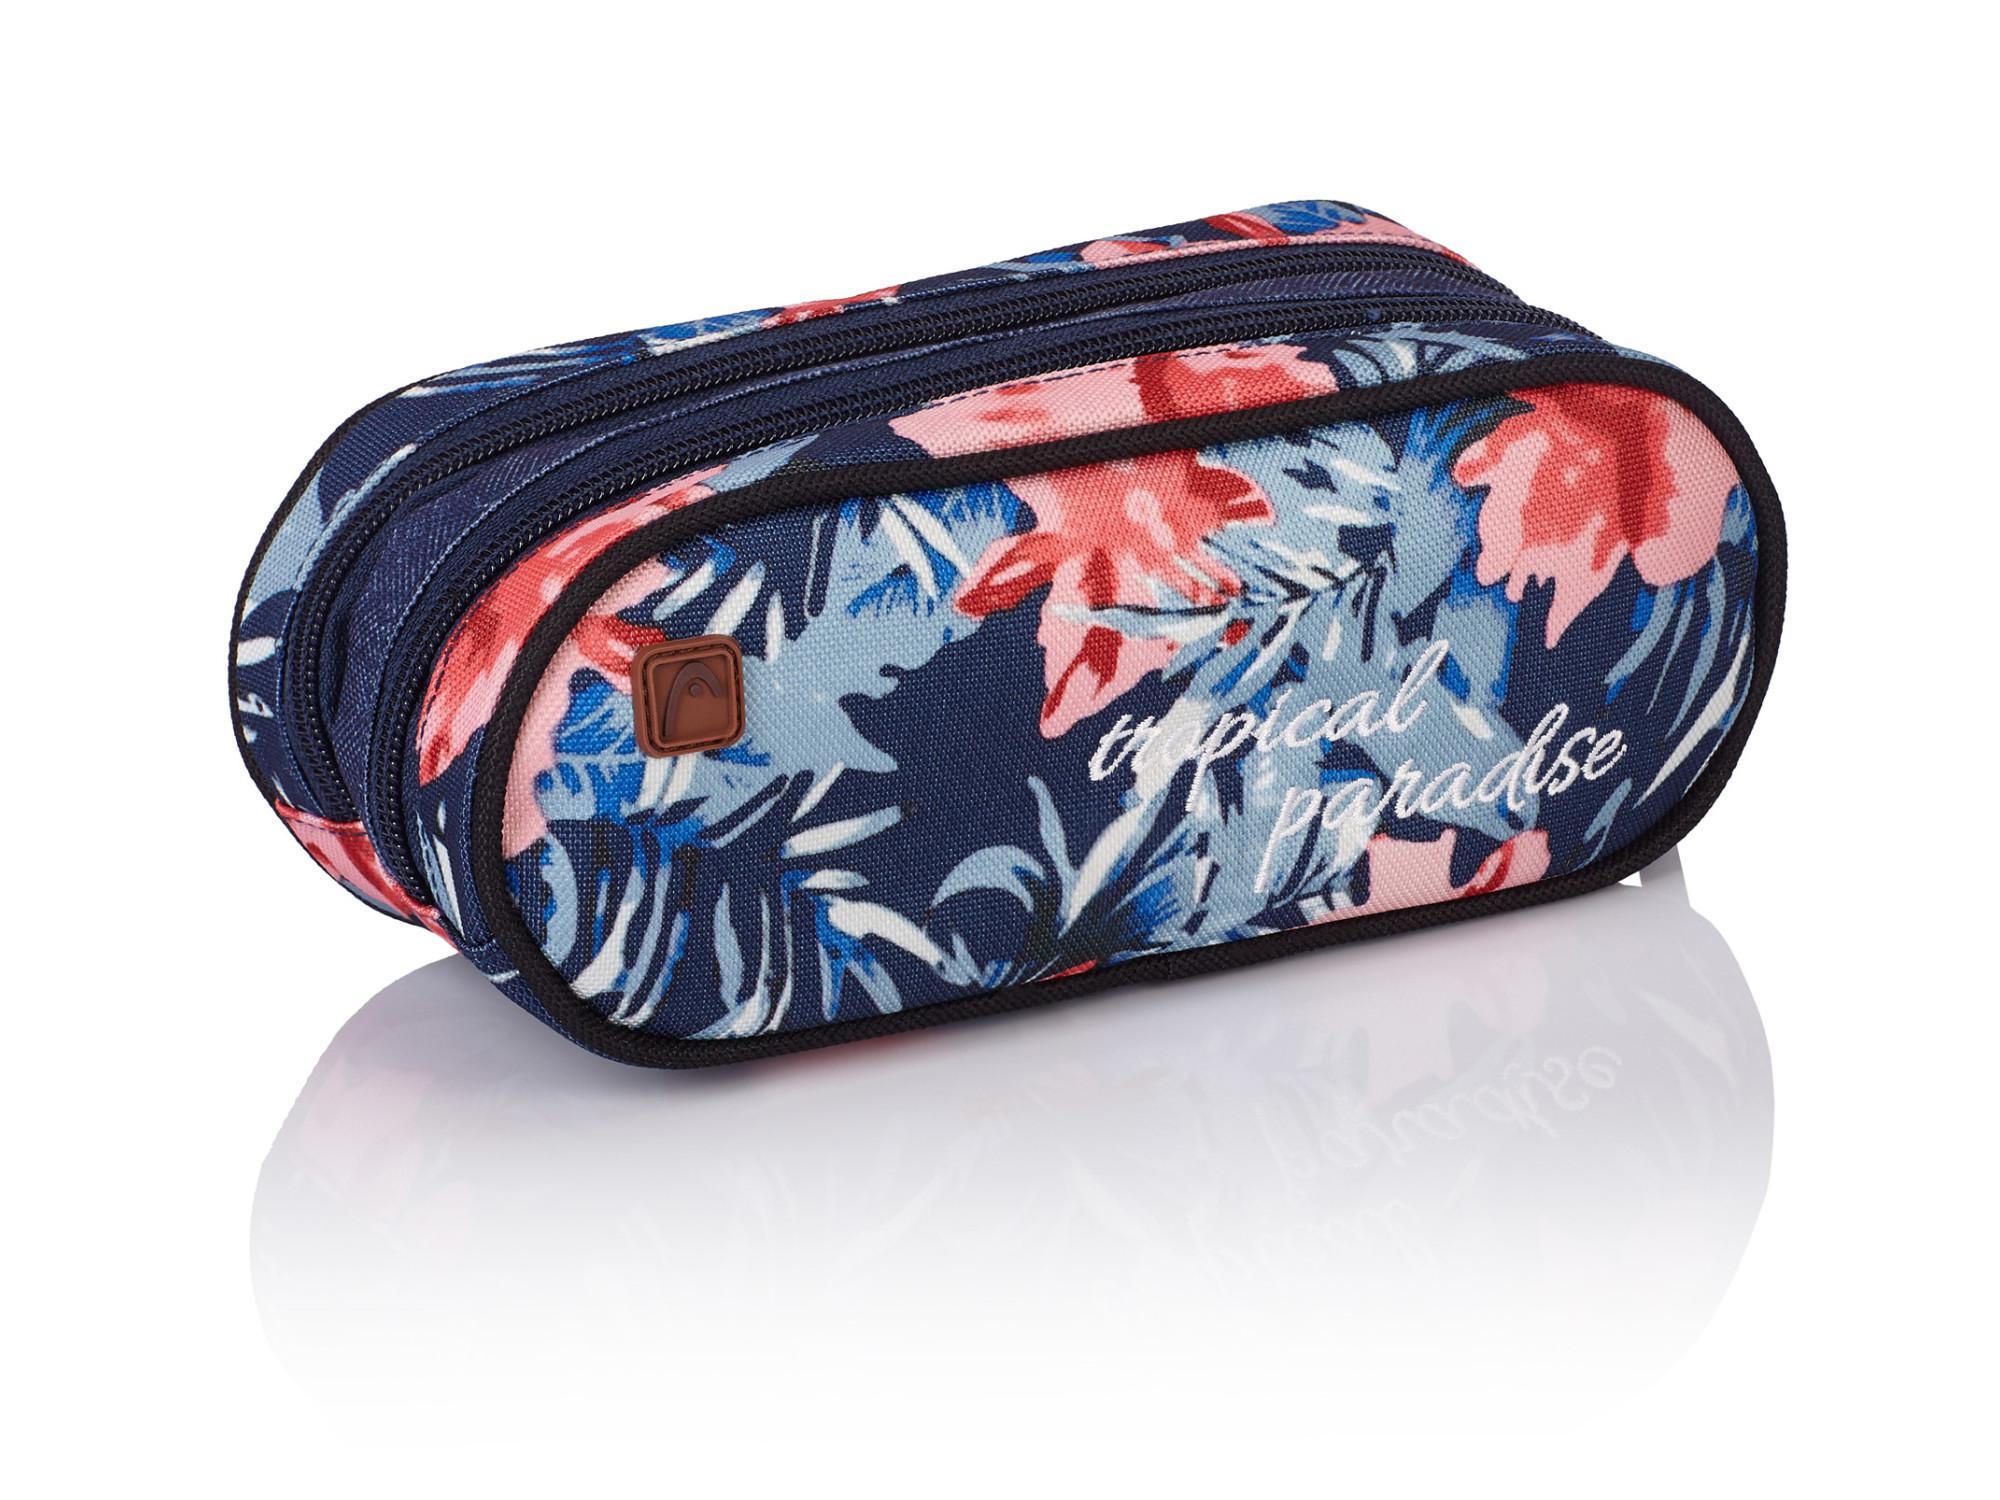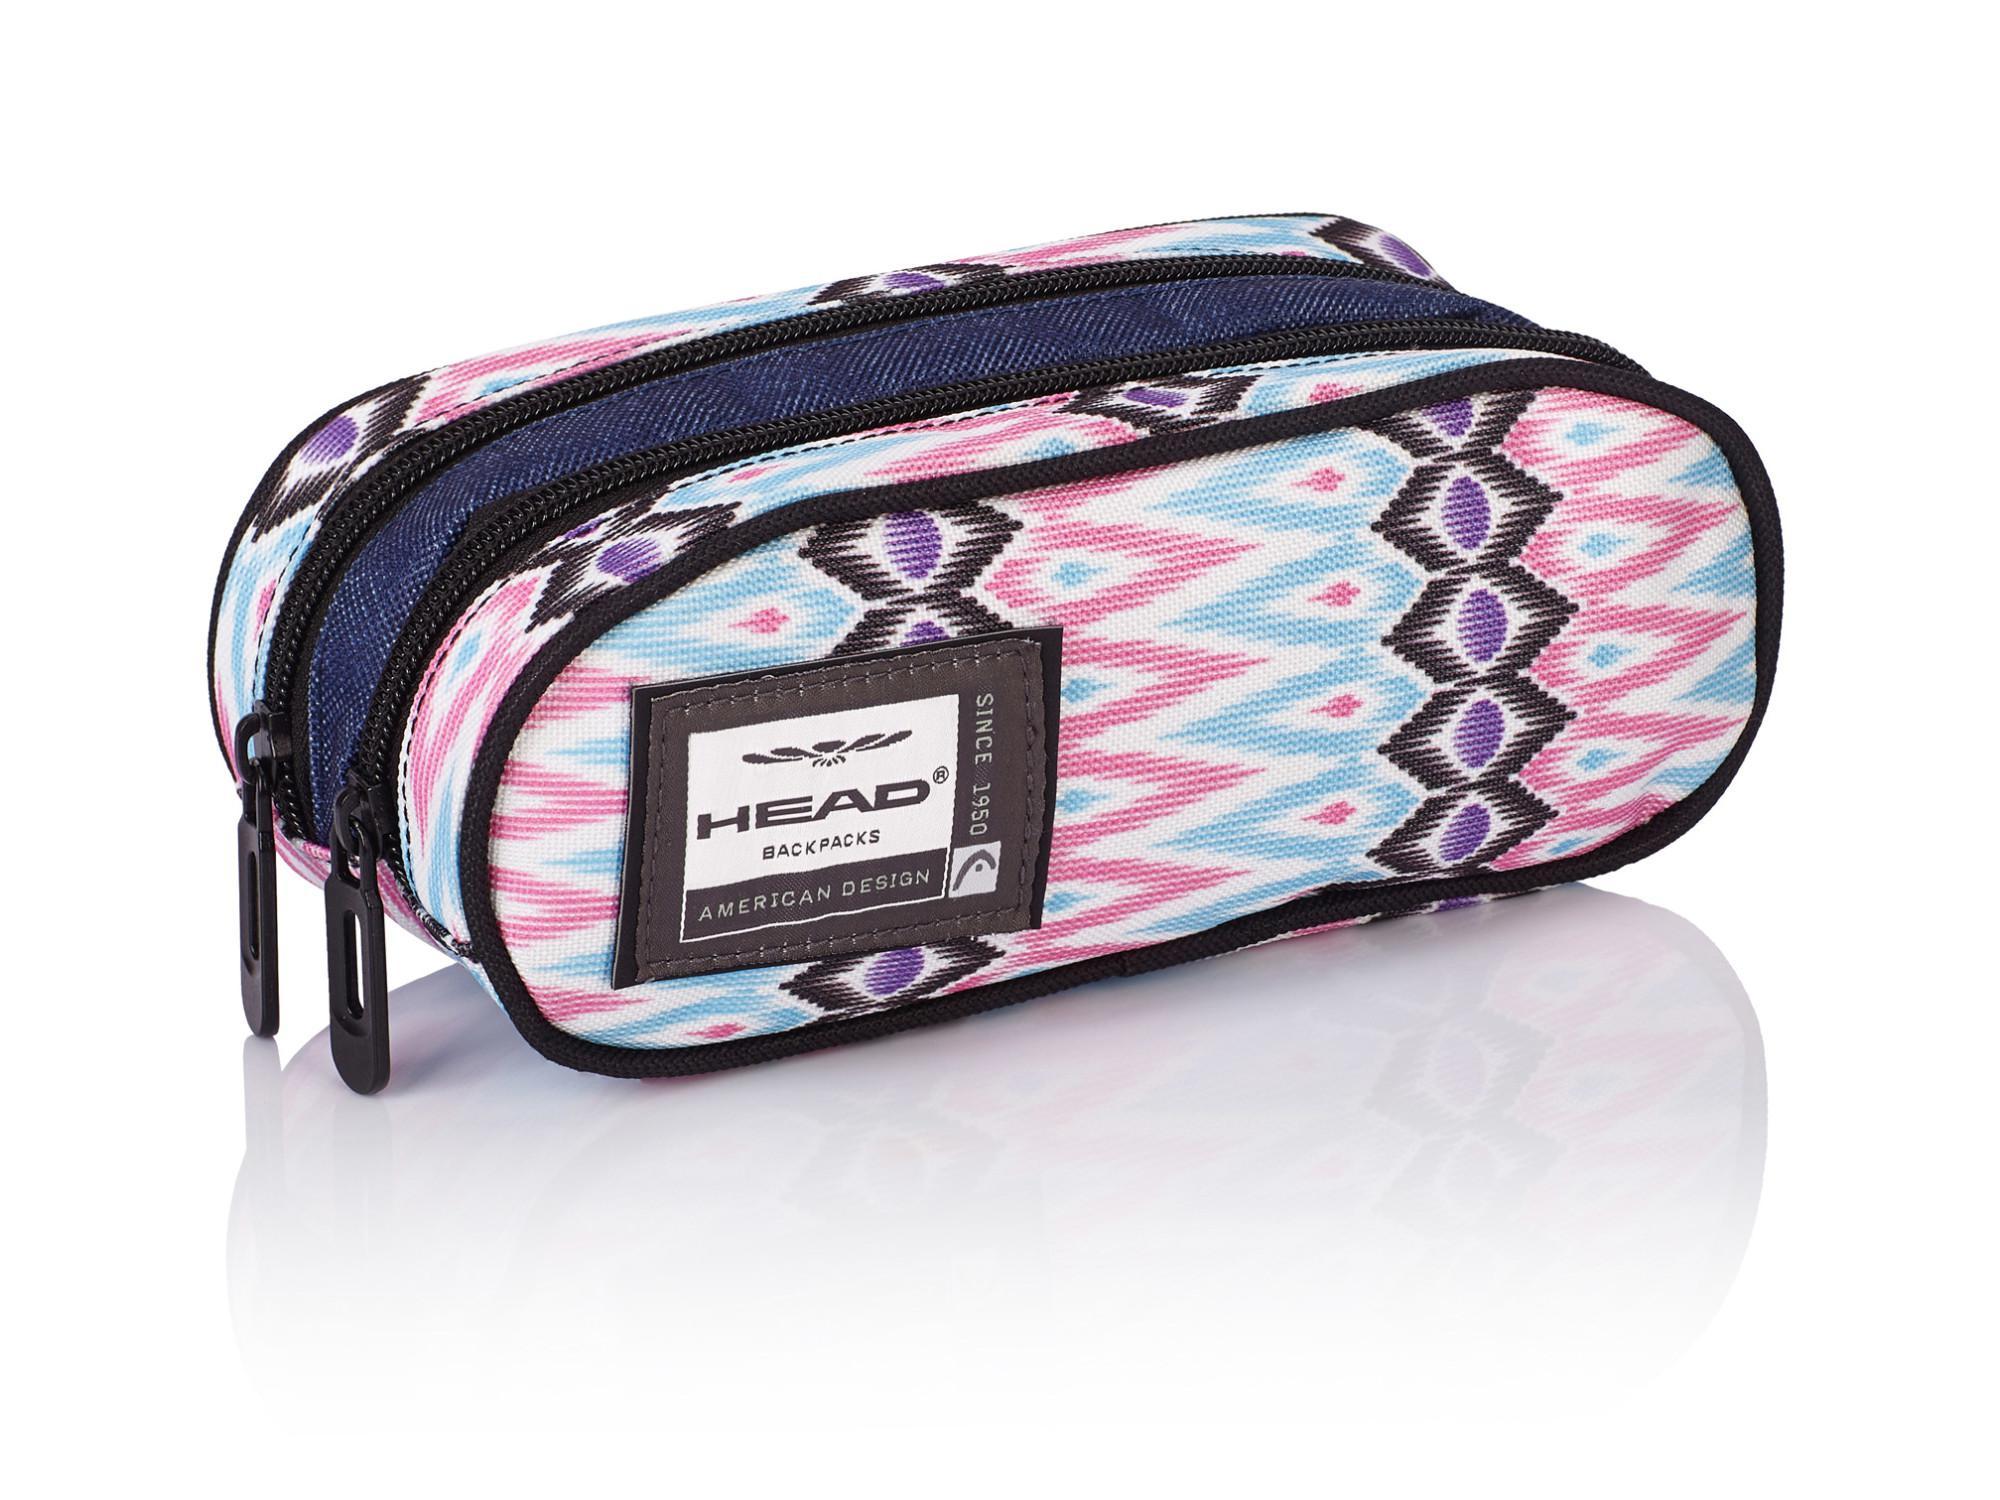The first image is the image on the left, the second image is the image on the right. Examine the images to the left and right. Is the description "in the image pair there are two oval shaped pencil pouches with cording on the outside" accurate? Answer yes or no. Yes. The first image is the image on the left, the second image is the image on the right. Considering the images on both sides, is "There is a Monster High pencil case." valid? Answer yes or no. No. 